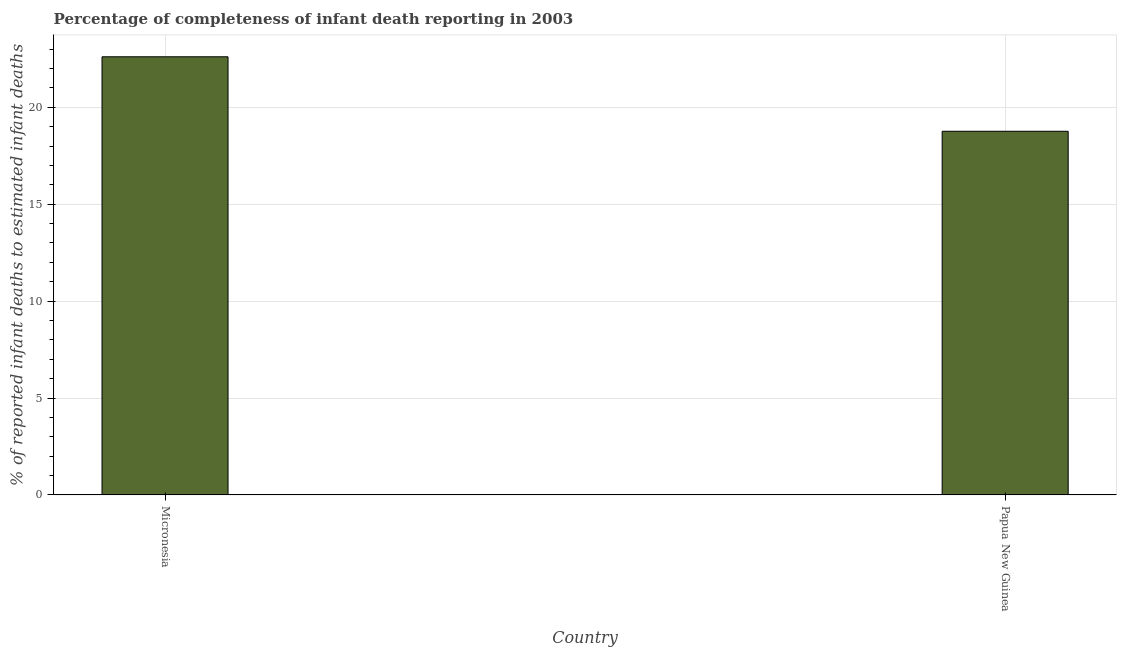Does the graph contain any zero values?
Give a very brief answer. No. What is the title of the graph?
Give a very brief answer. Percentage of completeness of infant death reporting in 2003. What is the label or title of the X-axis?
Your response must be concise. Country. What is the label or title of the Y-axis?
Provide a succinct answer. % of reported infant deaths to estimated infant deaths. What is the completeness of infant death reporting in Micronesia?
Your answer should be compact. 22.61. Across all countries, what is the maximum completeness of infant death reporting?
Your answer should be compact. 22.61. Across all countries, what is the minimum completeness of infant death reporting?
Keep it short and to the point. 18.77. In which country was the completeness of infant death reporting maximum?
Your answer should be very brief. Micronesia. In which country was the completeness of infant death reporting minimum?
Make the answer very short. Papua New Guinea. What is the sum of the completeness of infant death reporting?
Provide a short and direct response. 41.37. What is the difference between the completeness of infant death reporting in Micronesia and Papua New Guinea?
Provide a succinct answer. 3.84. What is the average completeness of infant death reporting per country?
Ensure brevity in your answer.  20.69. What is the median completeness of infant death reporting?
Offer a very short reply. 20.69. In how many countries, is the completeness of infant death reporting greater than 16 %?
Ensure brevity in your answer.  2. What is the ratio of the completeness of infant death reporting in Micronesia to that in Papua New Guinea?
Offer a very short reply. 1.21. In how many countries, is the completeness of infant death reporting greater than the average completeness of infant death reporting taken over all countries?
Your response must be concise. 1. How many bars are there?
Ensure brevity in your answer.  2. How many countries are there in the graph?
Provide a short and direct response. 2. What is the % of reported infant deaths to estimated infant deaths of Micronesia?
Make the answer very short. 22.61. What is the % of reported infant deaths to estimated infant deaths of Papua New Guinea?
Keep it short and to the point. 18.77. What is the difference between the % of reported infant deaths to estimated infant deaths in Micronesia and Papua New Guinea?
Your response must be concise. 3.84. What is the ratio of the % of reported infant deaths to estimated infant deaths in Micronesia to that in Papua New Guinea?
Your response must be concise. 1.21. 